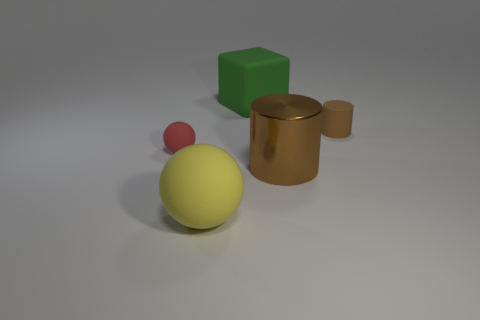Are there any brown things left of the red rubber thing?
Offer a very short reply. No. What number of large objects are either brown rubber objects or rubber blocks?
Your response must be concise. 1. Is the big brown object made of the same material as the large green object?
Your answer should be very brief. No. There is another cylinder that is the same color as the small cylinder; what size is it?
Your answer should be compact. Large. Are there any things of the same color as the block?
Your answer should be compact. No. There is a green thing that is the same material as the tiny brown thing; what is its size?
Your answer should be compact. Large. There is a small matte object that is behind the rubber ball behind the thing that is in front of the big cylinder; what shape is it?
Provide a succinct answer. Cylinder. There is another brown object that is the same shape as the brown rubber thing; what size is it?
Give a very brief answer. Large. There is a rubber thing that is behind the large brown shiny thing and to the left of the large green object; what is its size?
Provide a short and direct response. Small. The other tiny thing that is the same color as the shiny object is what shape?
Offer a terse response. Cylinder. 